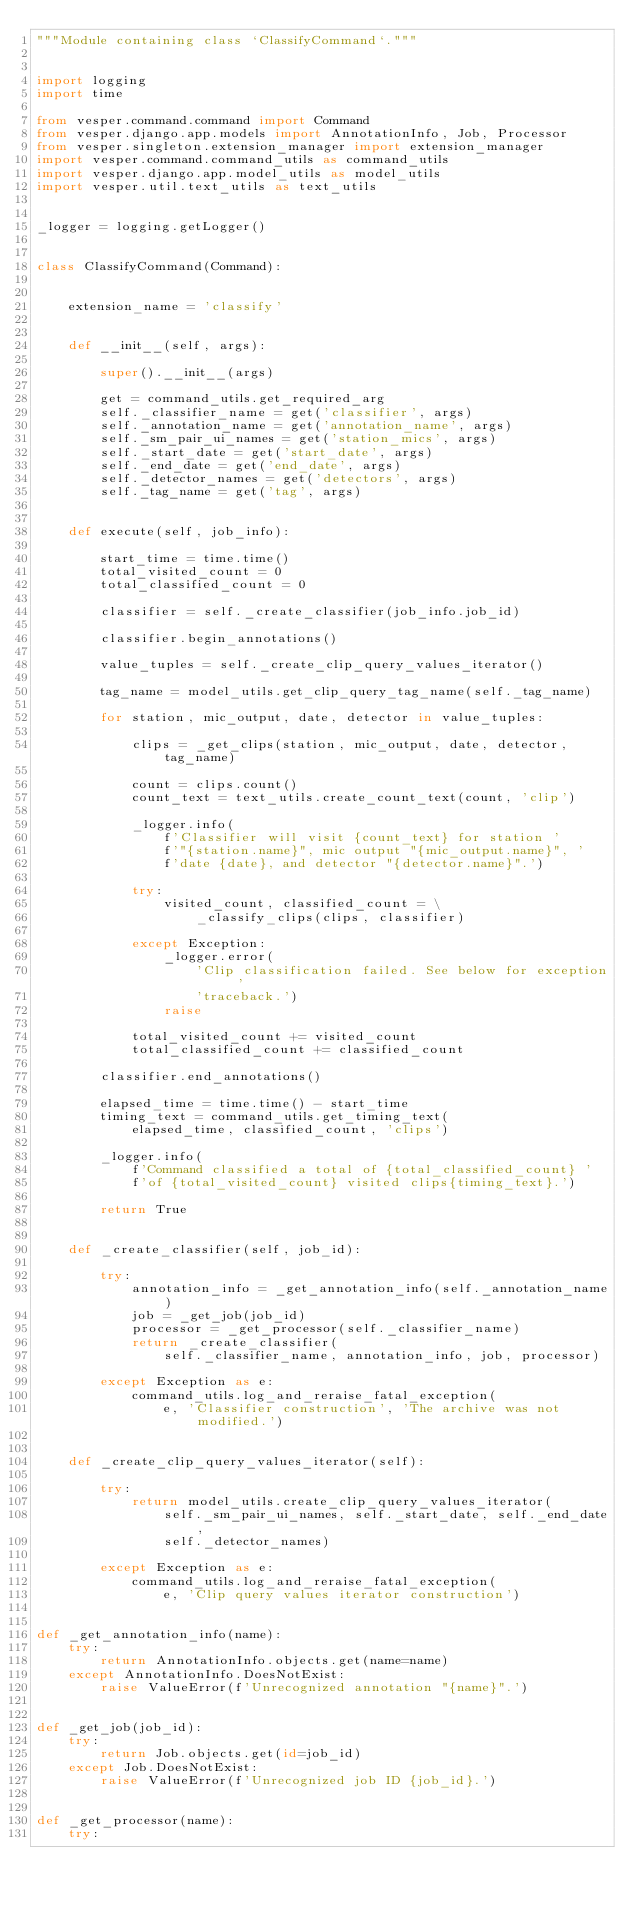Convert code to text. <code><loc_0><loc_0><loc_500><loc_500><_Python_>"""Module containing class `ClassifyCommand`."""


import logging
import time

from vesper.command.command import Command
from vesper.django.app.models import AnnotationInfo, Job, Processor
from vesper.singleton.extension_manager import extension_manager
import vesper.command.command_utils as command_utils
import vesper.django.app.model_utils as model_utils
import vesper.util.text_utils as text_utils


_logger = logging.getLogger()


class ClassifyCommand(Command):
    
    
    extension_name = 'classify'
    
    
    def __init__(self, args):
        
        super().__init__(args)
        
        get = command_utils.get_required_arg
        self._classifier_name = get('classifier', args)
        self._annotation_name = get('annotation_name', args)
        self._sm_pair_ui_names = get('station_mics', args)
        self._start_date = get('start_date', args)
        self._end_date = get('end_date', args)
        self._detector_names = get('detectors', args)
        self._tag_name = get('tag', args)
        

    def execute(self, job_info):
        
        start_time = time.time()
        total_visited_count = 0
        total_classified_count = 0

        classifier = self._create_classifier(job_info.job_id)
        
        classifier.begin_annotations()
    
        value_tuples = self._create_clip_query_values_iterator()
        
        tag_name = model_utils.get_clip_query_tag_name(self._tag_name)
 
        for station, mic_output, date, detector in value_tuples:
            
            clips = _get_clips(station, mic_output, date, detector, tag_name)
            
            count = clips.count()
            count_text = text_utils.create_count_text(count, 'clip')
            
            _logger.info(
                f'Classifier will visit {count_text} for station '
                f'"{station.name}", mic output "{mic_output.name}", '
                f'date {date}, and detector "{detector.name}".')
            
            try:
                visited_count, classified_count = \
                    _classify_clips(clips, classifier)
                    
            except Exception:
                _logger.error(
                    'Clip classification failed. See below for exception '
                    'traceback.')
                raise

            total_visited_count += visited_count
            total_classified_count += classified_count
            
        classifier.end_annotations()
    
        elapsed_time = time.time() - start_time
        timing_text = command_utils.get_timing_text(
            elapsed_time, classified_count, 'clips')
                
        _logger.info(
            f'Command classified a total of {total_classified_count} '
            f'of {total_visited_count} visited clips{timing_text}.')

        return True


    def _create_classifier(self, job_id):
        
        try:
            annotation_info = _get_annotation_info(self._annotation_name)
            job = _get_job(job_id)
            processor = _get_processor(self._classifier_name)
            return _create_classifier(
                self._classifier_name, annotation_info, job, processor)
        
        except Exception as e:
            command_utils.log_and_reraise_fatal_exception(
                e, 'Classifier construction', 'The archive was not modified.')
        

    def _create_clip_query_values_iterator(self):
        
        try:
            return model_utils.create_clip_query_values_iterator(
                self._sm_pair_ui_names, self._start_date, self._end_date,
                self._detector_names)
            
        except Exception as e:
            command_utils.log_and_reraise_fatal_exception(
                e, 'Clip query values iterator construction')
            
            
def _get_annotation_info(name):
    try:
        return AnnotationInfo.objects.get(name=name)
    except AnnotationInfo.DoesNotExist:
        raise ValueError(f'Unrecognized annotation "{name}".')
    
        
def _get_job(job_id):
    try:
        return Job.objects.get(id=job_id)
    except Job.DoesNotExist:
        raise ValueError(f'Unrecognized job ID {job_id}.')
        

def _get_processor(name):
    try:</code> 